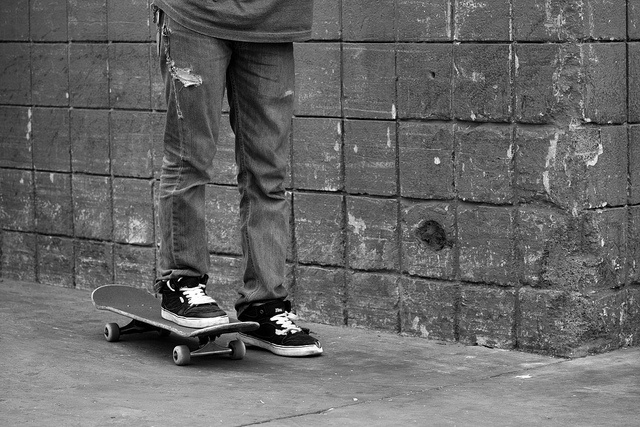Describe the objects in this image and their specific colors. I can see people in black, gray, darkgray, and lightgray tones and skateboard in black, gray, darkgray, and lightgray tones in this image. 